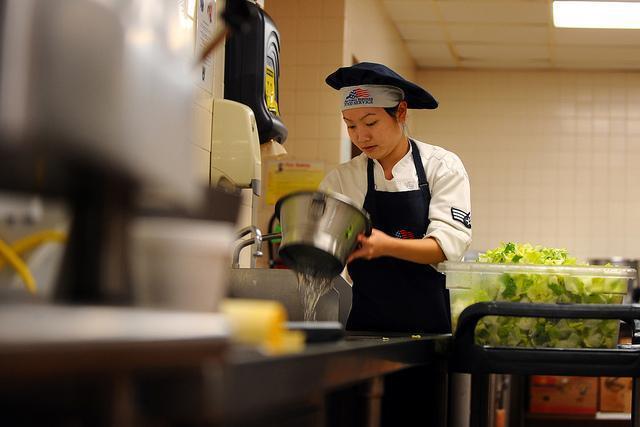How many sinks are there?
Give a very brief answer. 1. 